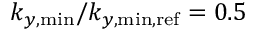Convert formula to latex. <formula><loc_0><loc_0><loc_500><loc_500>k _ { y , \min } / k _ { y , \min , r e f } = 0 . 5</formula> 